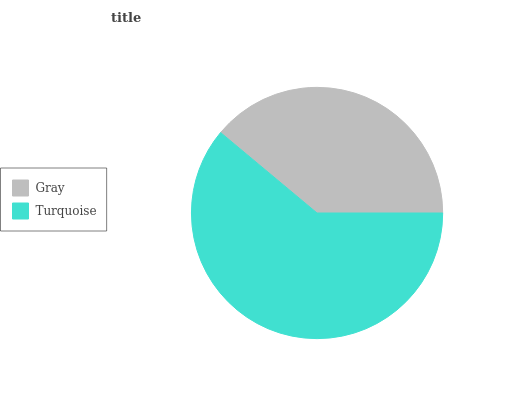Is Gray the minimum?
Answer yes or no. Yes. Is Turquoise the maximum?
Answer yes or no. Yes. Is Turquoise the minimum?
Answer yes or no. No. Is Turquoise greater than Gray?
Answer yes or no. Yes. Is Gray less than Turquoise?
Answer yes or no. Yes. Is Gray greater than Turquoise?
Answer yes or no. No. Is Turquoise less than Gray?
Answer yes or no. No. Is Turquoise the high median?
Answer yes or no. Yes. Is Gray the low median?
Answer yes or no. Yes. Is Gray the high median?
Answer yes or no. No. Is Turquoise the low median?
Answer yes or no. No. 